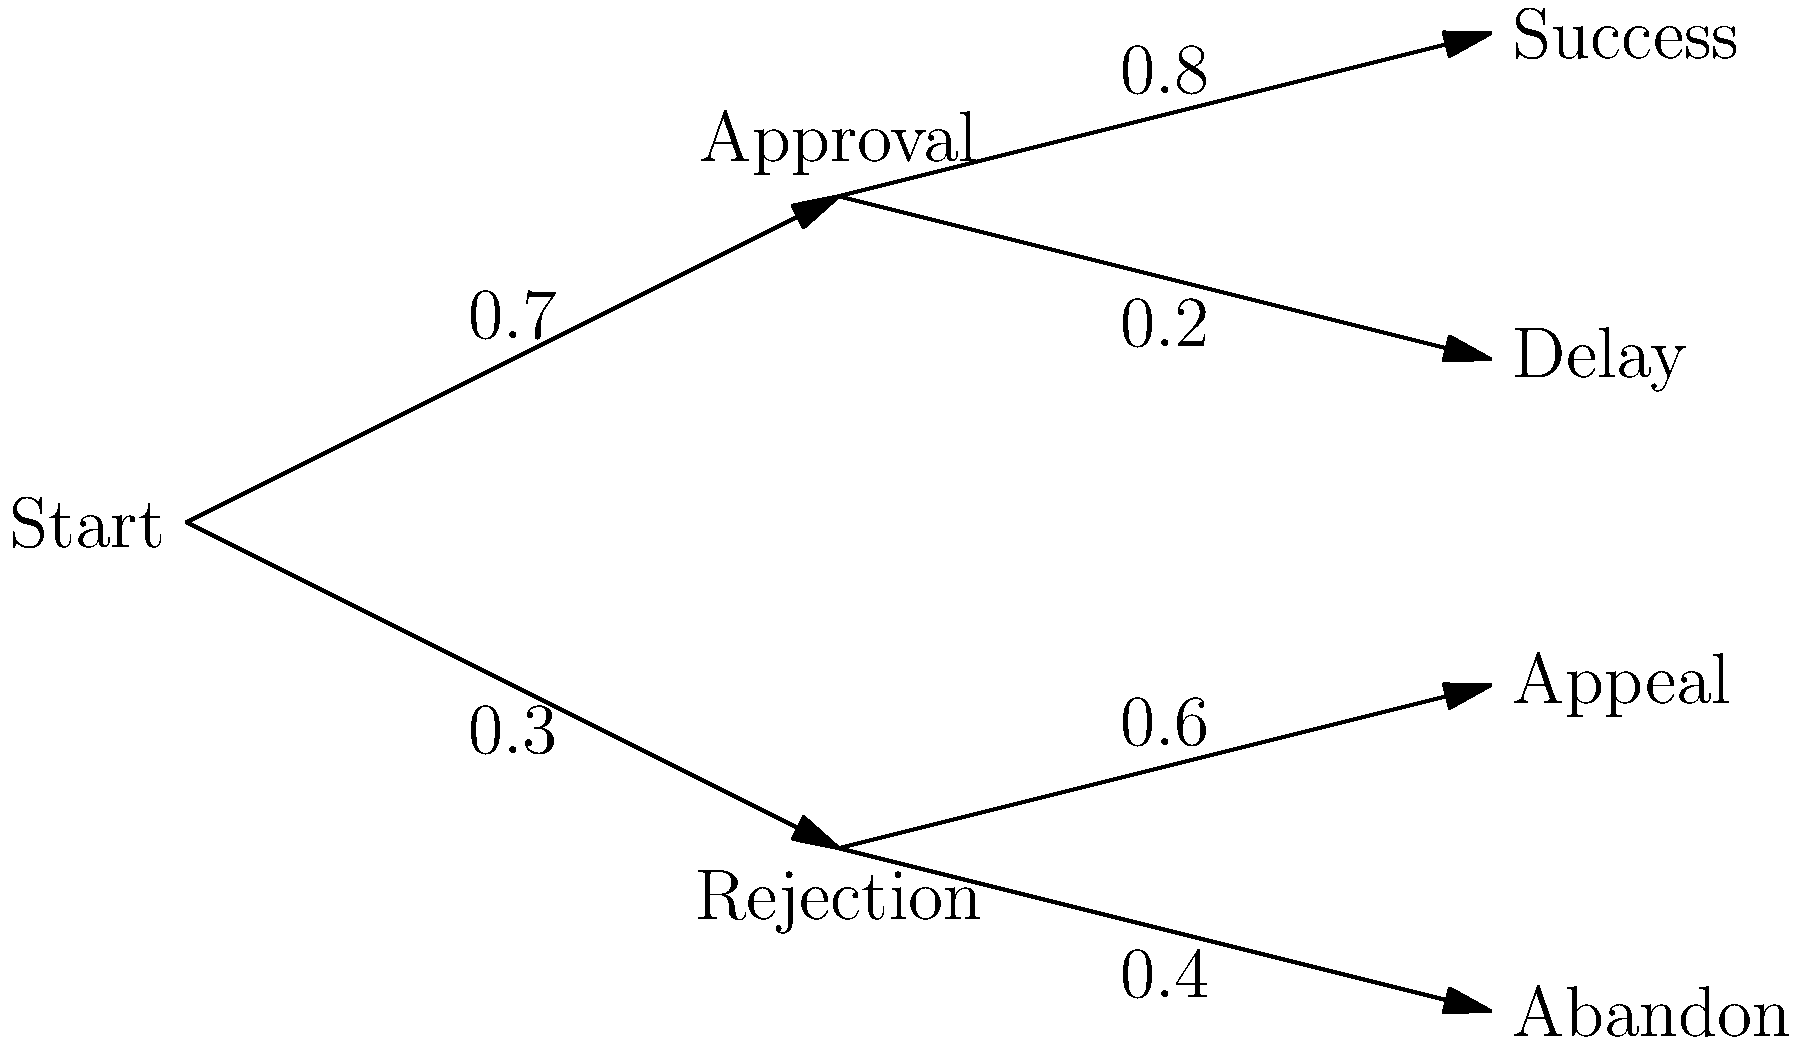As a project manager, you're analyzing the risks associated with a new development project using a decision tree. The tree shows the probability of initial approval is 0.7, and if approved, the probability of project success is 0.8. If rejected, there's a 0.6 probability of a successful appeal. What is the overall probability of project success (either through initial approval or successful appeal)? Let's break this down step-by-step:

1. There are two paths to success:
   a) Initial approval followed by project success
   b) Initial rejection followed by a successful appeal

2. For path a:
   - Probability of initial approval = 0.7
   - Probability of project success after approval = 0.8
   - Probability of this path = $0.7 \times 0.8 = 0.56$

3. For path b:
   - Probability of initial rejection = $1 - 0.7 = 0.3$
   - Probability of successful appeal = 0.6
   - Probability of this path = $0.3 \times 0.6 = 0.18$

4. The overall probability of success is the sum of these two paths:
   $0.56 + 0.18 = 0.74$

Therefore, the overall probability of project success is 0.74 or 74%.
Answer: 0.74 